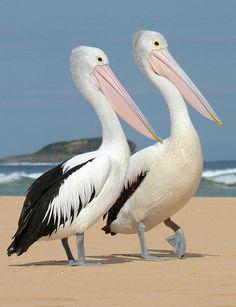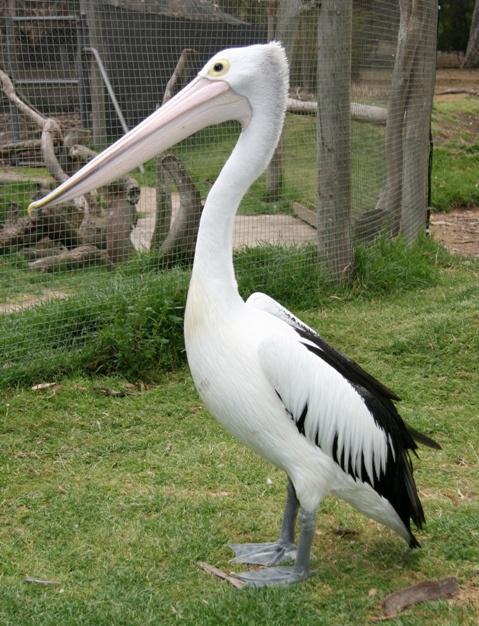The first image is the image on the left, the second image is the image on the right. For the images displayed, is the sentence "One of the images contains exactly two birds." factually correct? Answer yes or no. Yes. 